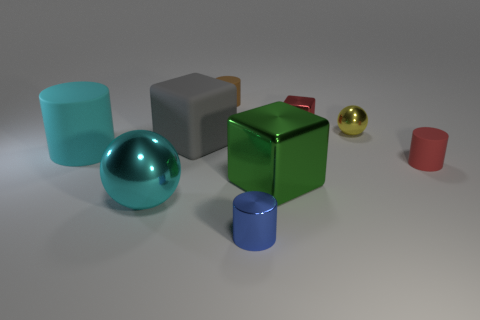Subtract all metallic blocks. How many blocks are left? 1 Subtract all cyan cylinders. How many cylinders are left? 3 Subtract all cubes. How many objects are left? 6 Subtract 1 cylinders. How many cylinders are left? 3 Subtract all purple blocks. Subtract all yellow balls. How many blocks are left? 3 Subtract all purple metallic blocks. Subtract all large objects. How many objects are left? 5 Add 6 small red metal blocks. How many small red metal blocks are left? 7 Add 5 small cubes. How many small cubes exist? 6 Subtract 0 purple blocks. How many objects are left? 9 